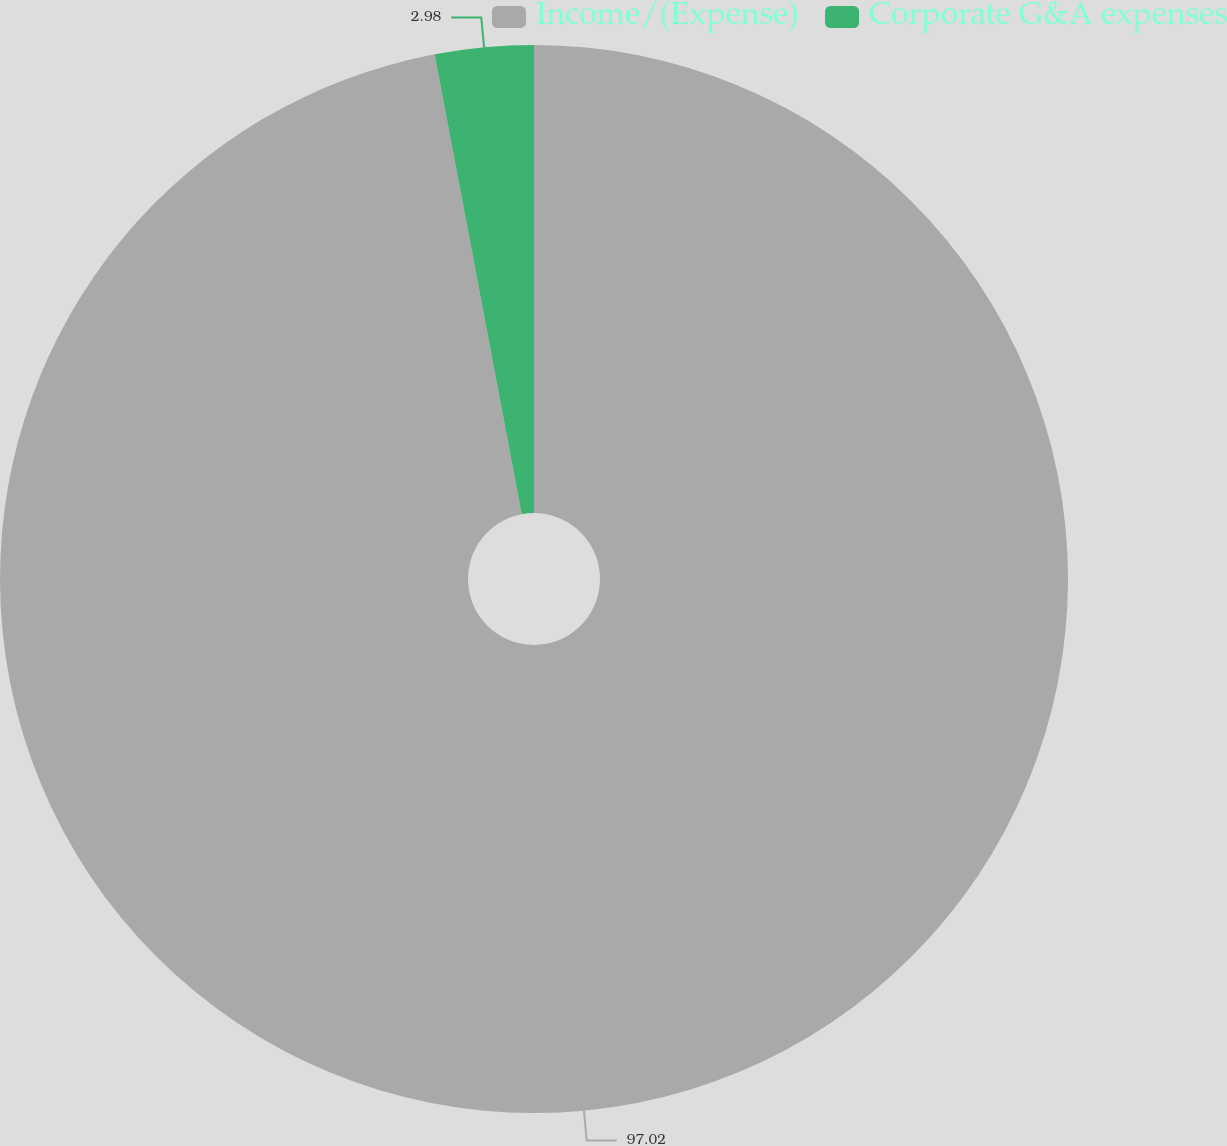<chart> <loc_0><loc_0><loc_500><loc_500><pie_chart><fcel>Income/(Expense)<fcel>Corporate G&A expenses<nl><fcel>97.02%<fcel>2.98%<nl></chart> 